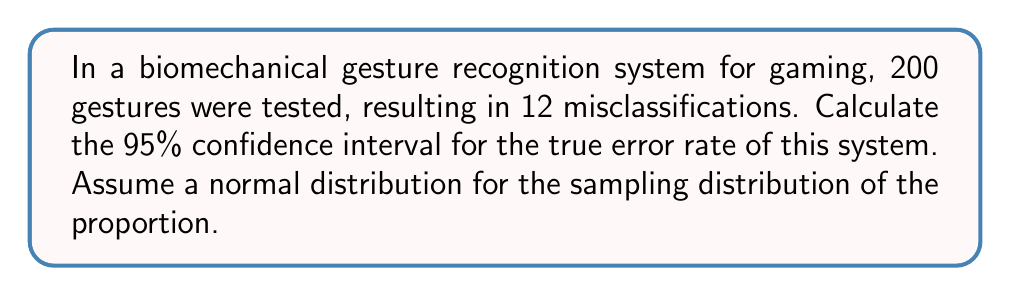What is the answer to this math problem? Let's approach this step-by-step:

1) First, we need to calculate the sample proportion (p̂):
   $$\hat{p} = \frac{\text{number of errors}}{\text{total number of trials}} = \frac{12}{200} = 0.06$$

2) For a 95% confidence interval, we use a z-score of 1.96.

3) The formula for the confidence interval of a proportion is:
   $$\hat{p} \pm z \sqrt{\frac{\hat{p}(1-\hat{p})}{n}}$$

   Where:
   - $\hat{p}$ is the sample proportion
   - $z$ is the z-score (1.96 for 95% CI)
   - $n$ is the sample size

4) Let's calculate the margin of error:
   $$\text{Margin of Error} = 1.96 \sqrt{\frac{0.06(1-0.06)}{200}}$$
   $$= 1.96 \sqrt{\frac{0.0564}{200}} = 1.96 \sqrt{0.000282} = 1.96 * 0.0168 = 0.0329$$

5) Now, we can calculate the confidence interval:
   Lower bound: $0.06 - 0.0329 = 0.0271$
   Upper bound: $0.06 + 0.0329 = 0.0929$

6) Convert to percentage:
   Lower bound: $2.71\%$
   Upper bound: $9.29\%$
Answer: (2.71%, 9.29%) 